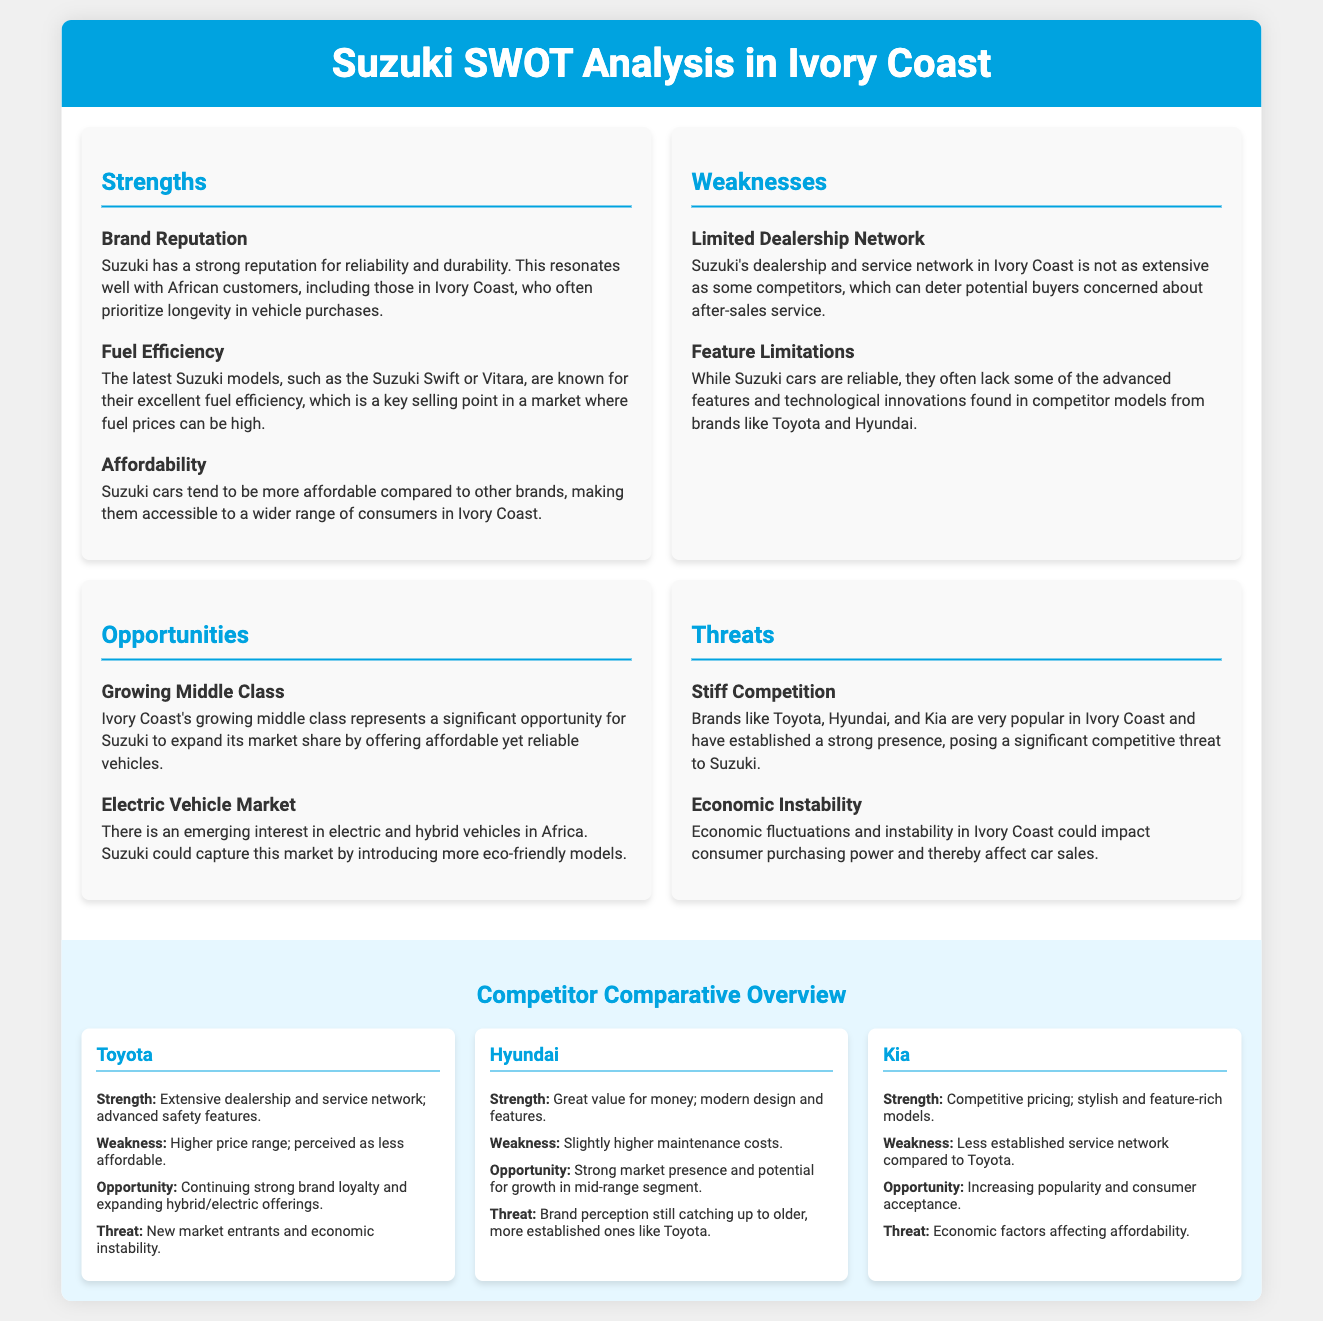What is one of Suzuki's strengths in the Ivory Coast market? The document lists "Brand Reputation" as a strength of Suzuki, emphasizing reliability and durability.
Answer: Brand Reputation What feature of Suzuki models is highlighted as a key selling point? Fuel efficiency is mentioned as a selling point, which is significant in markets with high fuel prices.
Answer: Fuel Efficiency What is a noted weakness of Suzuki cars? Limited dealership network is cited as a weakness that concerns potential buyers about after-sales service.
Answer: Limited Dealership Network What opportunity does Suzuki have in the Ivory Coast market? The document identifies the "Growing Middle Class" as an opportunity for market expansion.
Answer: Growing Middle Class Who are Suzuki's main competitors mentioned in the document? The SWOT analysis highlights Toyota, Hyundai, and Kia as competitors in the Ivory Coast market.
Answer: Toyota, Hyundai, and Kia What is a significant threat to Suzuki's market position? The document states "Stiff Competition" from established brands as a notable threat.
Answer: Stiff Competition What is the affordability status of Suzuki cars in comparison to other brands? The document indicates that Suzuki cars tend to be more affordable compared to competitors.
Answer: More affordable What opportunity exists for Suzuki in the emerging vehicle market? The document mentions a growing interest in "Electric Vehicle Market" as an opportunity for Suzuki.
Answer: Electric Vehicle Market What is a weakness of the Toyota brand according to the comparison provided? The document mentions that Toyota has a higher price range, making it less affordable.
Answer: Higher price range 